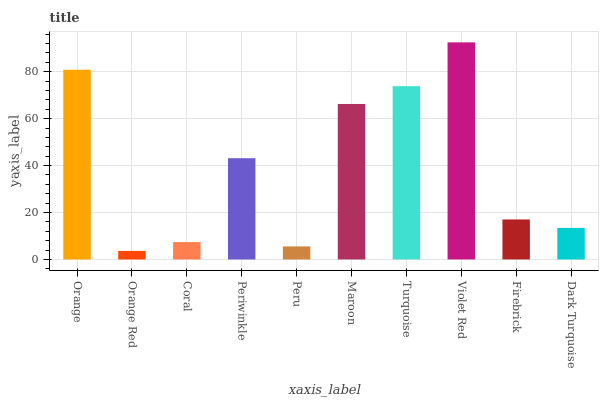Is Orange Red the minimum?
Answer yes or no. Yes. Is Violet Red the maximum?
Answer yes or no. Yes. Is Coral the minimum?
Answer yes or no. No. Is Coral the maximum?
Answer yes or no. No. Is Coral greater than Orange Red?
Answer yes or no. Yes. Is Orange Red less than Coral?
Answer yes or no. Yes. Is Orange Red greater than Coral?
Answer yes or no. No. Is Coral less than Orange Red?
Answer yes or no. No. Is Periwinkle the high median?
Answer yes or no. Yes. Is Firebrick the low median?
Answer yes or no. Yes. Is Coral the high median?
Answer yes or no. No. Is Violet Red the low median?
Answer yes or no. No. 